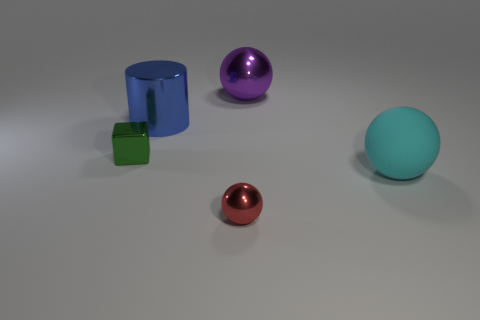Are there any other things that are the same material as the big cyan sphere?
Give a very brief answer. No. What is the size of the rubber sphere?
Offer a very short reply. Large. What number of red metallic balls are the same size as the green metallic cube?
Your answer should be compact. 1. Is the sphere to the left of the purple ball made of the same material as the big thing behind the blue thing?
Make the answer very short. Yes. The small object that is behind the tiny object in front of the big cyan thing is made of what material?
Offer a very short reply. Metal. There is a large object in front of the cylinder; what material is it?
Provide a short and direct response. Rubber. How many red shiny things have the same shape as the cyan object?
Ensure brevity in your answer.  1. Is the color of the rubber thing the same as the tiny metallic cube?
Make the answer very short. No. There is a blue object behind the green object behind the red metal object that is right of the large blue cylinder; what is its material?
Ensure brevity in your answer.  Metal. Are there any objects to the right of the green cube?
Offer a very short reply. Yes. 